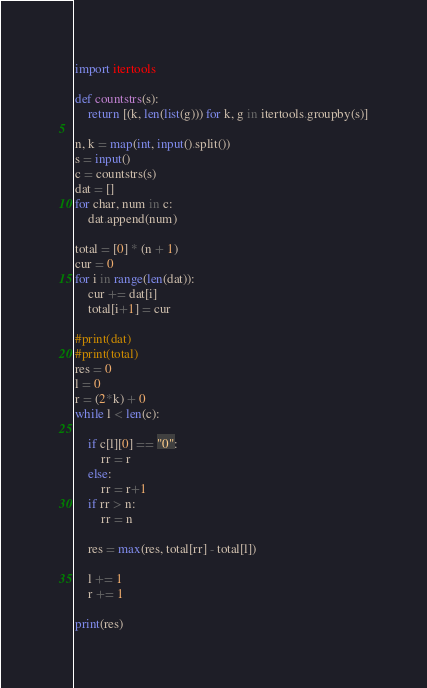<code> <loc_0><loc_0><loc_500><loc_500><_Python_>import itertools

def countstrs(s):
    return [(k, len(list(g))) for k, g in itertools.groupby(s)]

n, k = map(int, input().split())
s = input()
c = countstrs(s)
dat = []
for char, num in c:
    dat.append(num)

total = [0] * (n + 1)
cur = 0
for i in range(len(dat)):
    cur += dat[i]
    total[i+1] = cur

#print(dat)
#print(total)
res = 0
l = 0
r = (2*k) + 0
while l < len(c):

    if c[l][0] == "0":
        rr = r
    else:
        rr = r+1
    if rr > n:
        rr = n

    res = max(res, total[rr] - total[l])

    l += 1
    r += 1

print(res)</code> 